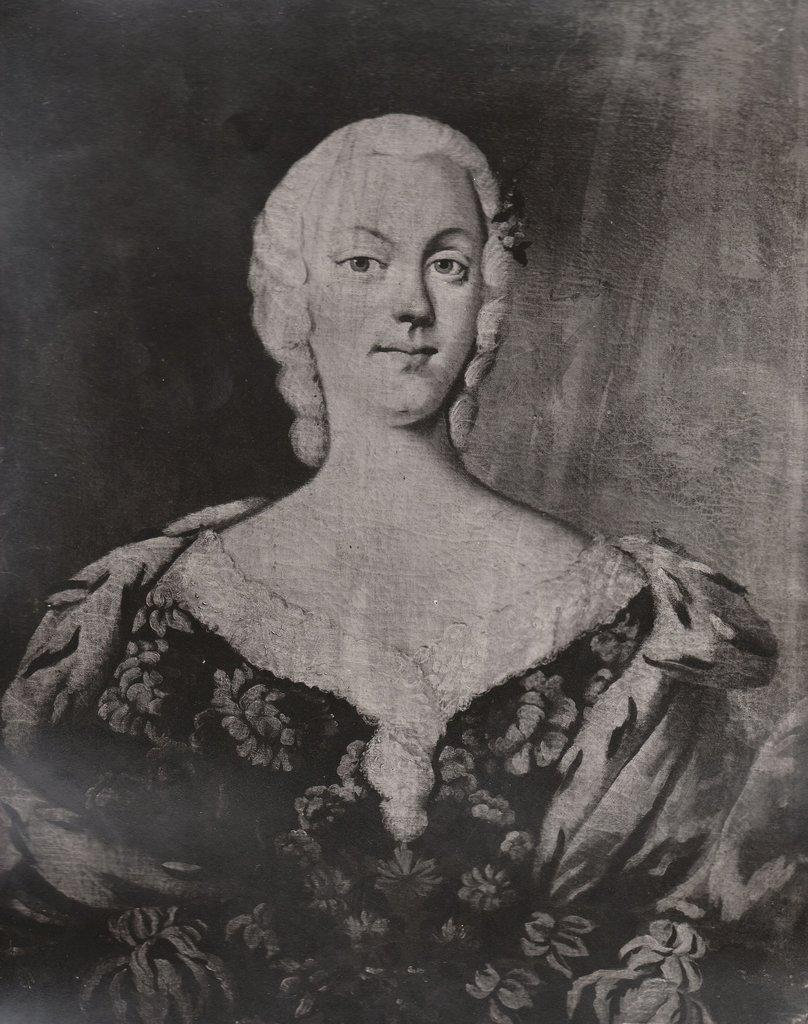What is the main subject of the image? There is a photograph in the image. Can you describe the photograph? The photograph is black and white and depicts a woman. What type of flame can be seen in the image? There is no flame present in the image; it features a black and white photograph of a woman. How much has the soda increased in the image? There is no soda present in the image, so it cannot be determined if it has increased or not. 